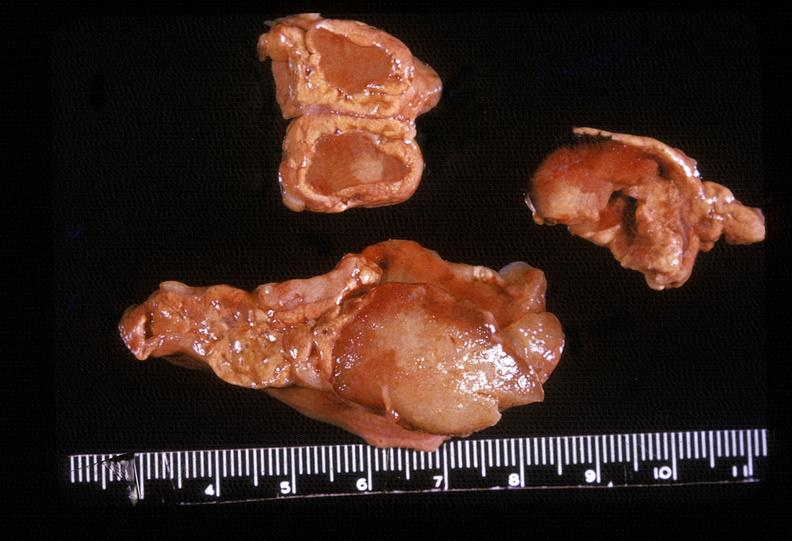s endocrine present?
Answer the question using a single word or phrase. Yes 